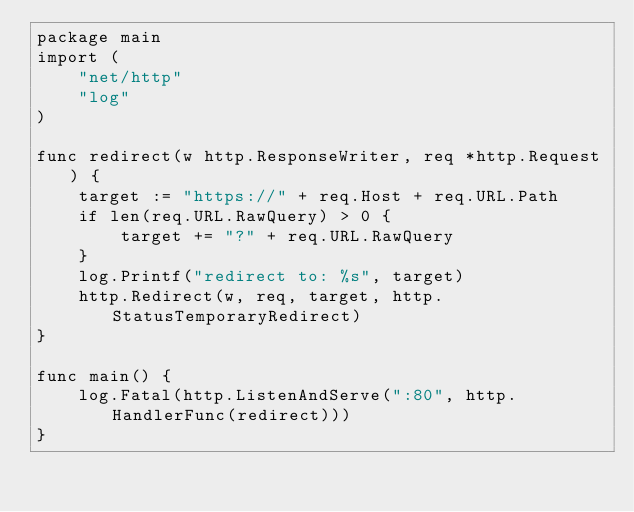<code> <loc_0><loc_0><loc_500><loc_500><_Go_>package main
import (
	"net/http"
	"log"
)

func redirect(w http.ResponseWriter, req *http.Request) {
	target := "https://" + req.Host + req.URL.Path
	if len(req.URL.RawQuery) > 0 {
		target += "?" + req.URL.RawQuery
	}
	log.Printf("redirect to: %s", target)
	http.Redirect(w, req, target, http.StatusTemporaryRedirect)
}

func main() {
	log.Fatal(http.ListenAndServe(":80", http.HandlerFunc(redirect)))
}
</code> 